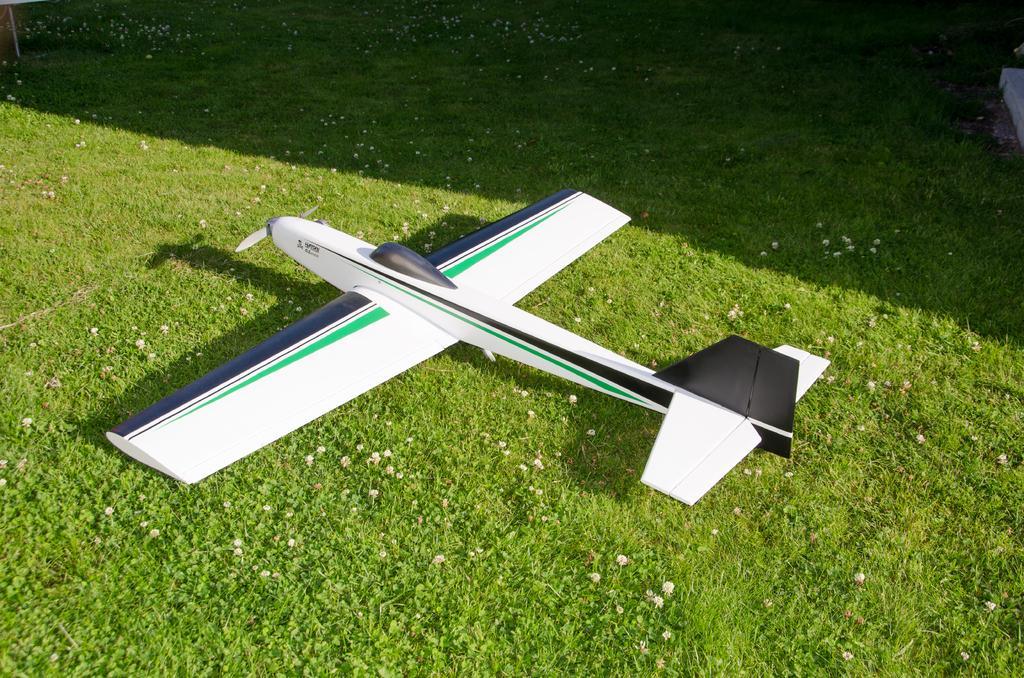Describe this image in one or two sentences. In this image there is a toy aircraft on the ground. There is grass on the ground. There are small flowers on the ground. 